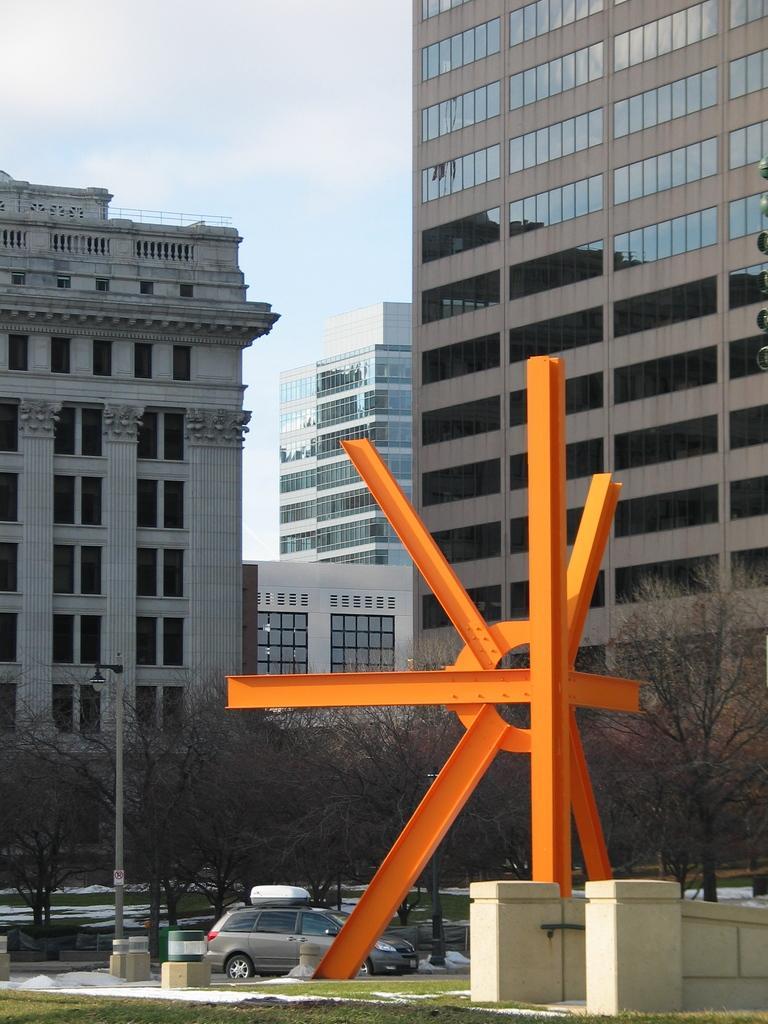In one or two sentences, can you explain what this image depicts? This image is taken outdoors. At the bottom of the image there is a ground with grass on it. At the top of the image there is a sky with clouds. In the middle of the image there are a few buildings with walls, windows, railings and roofs. There are a few trees and a car is moving on the road. There is a street light. On the right side of the image there is a wall and there are a few iron bars. 